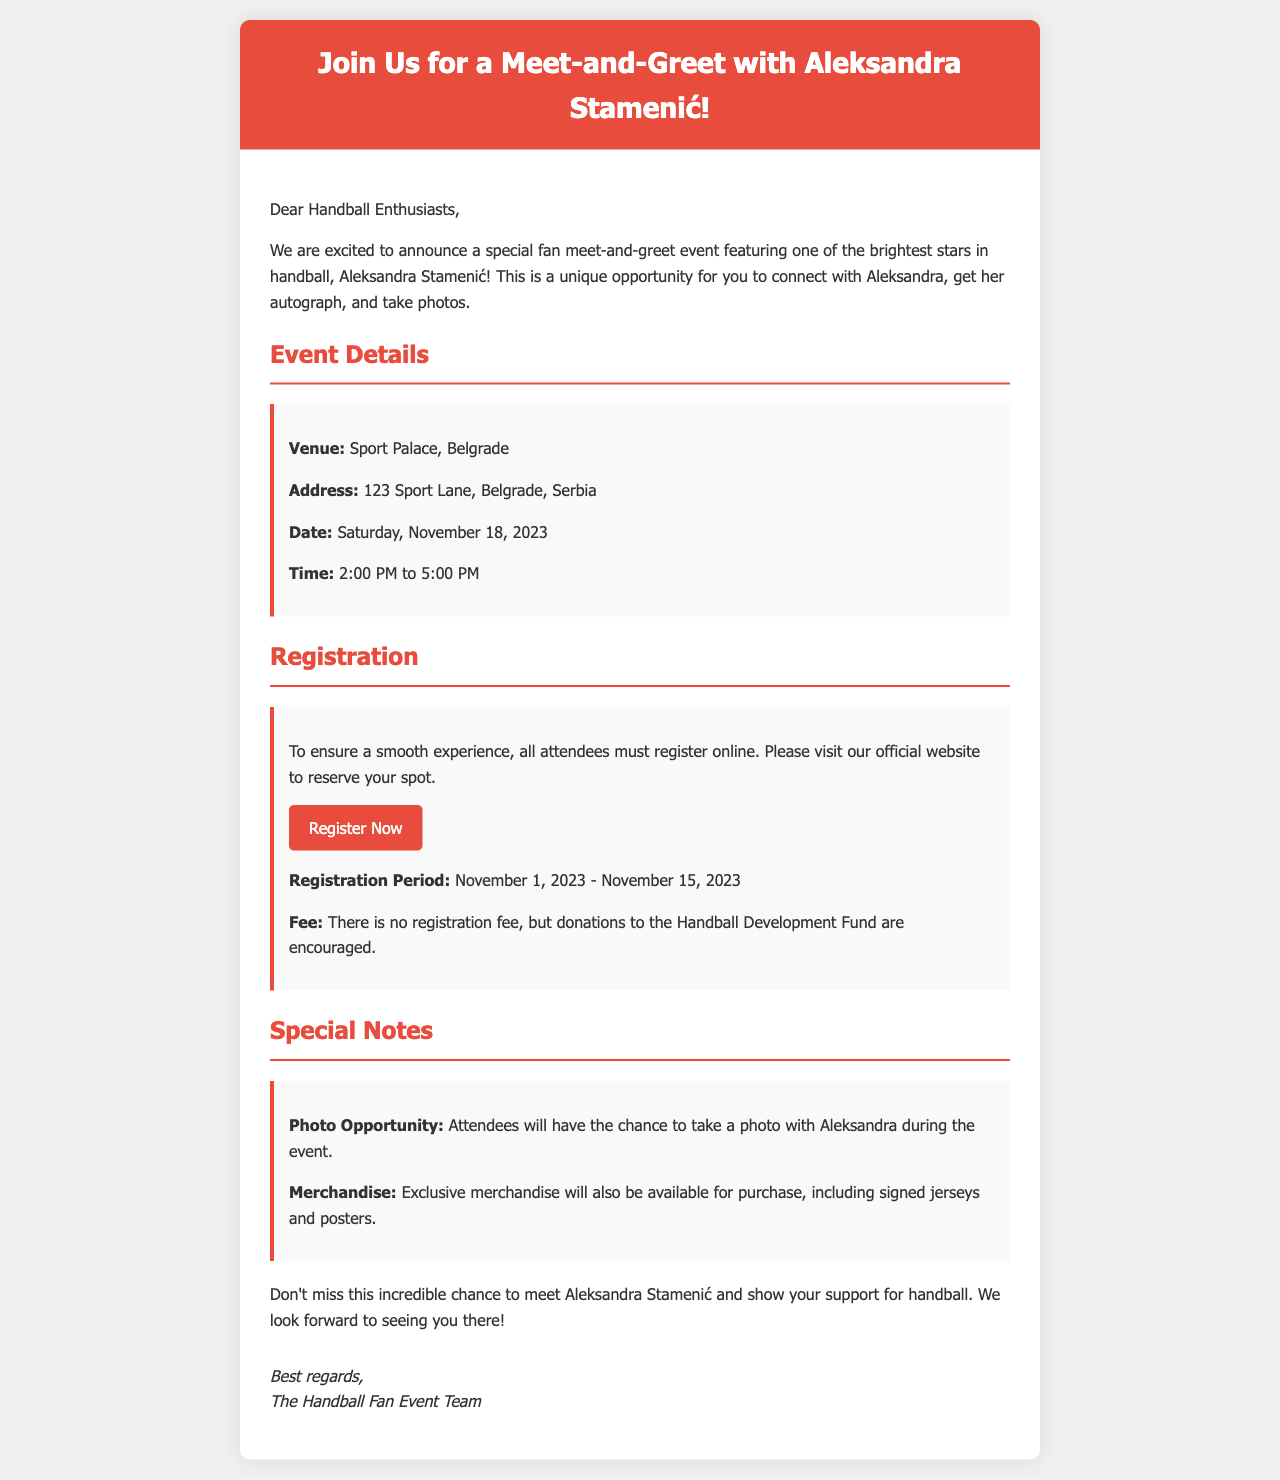what is the venue for the event? The venue is mentioned as the location for the meet-and-greet with Aleksandra Stamenić.
Answer: Sport Palace, Belgrade what is the address of the venue? The address provides specific location details for the Sport Palace in Belgrade.
Answer: 123 Sport Lane, Belgrade, Serbia when is the meet-and-greet scheduled? The date of the event is highlighted in the document.
Answer: Saturday, November 18, 2023 what time does the event start? The starting time for the meet-and-greet with Aleksandra is specified in the event details.
Answer: 2:00 PM what is the registration period? The registration period for attendees is clearly stated in the document.
Answer: November 1, 2023 - November 15, 2023 is there a fee to register for the event? The document mentions whether registration requires a fee or not.
Answer: No what is encouraged during registration? The document highlights suggestions regarding contributions during registration.
Answer: Donations to the Handball Development Fund what unique opportunity will attendees have? The document mentions a specific activity that attendees can participate in during the event.
Answer: Photo Opportunity what merchandise will be available? The document specifies what kind of merchandise will be for sale at the event.
Answer: Signed jerseys and posters 